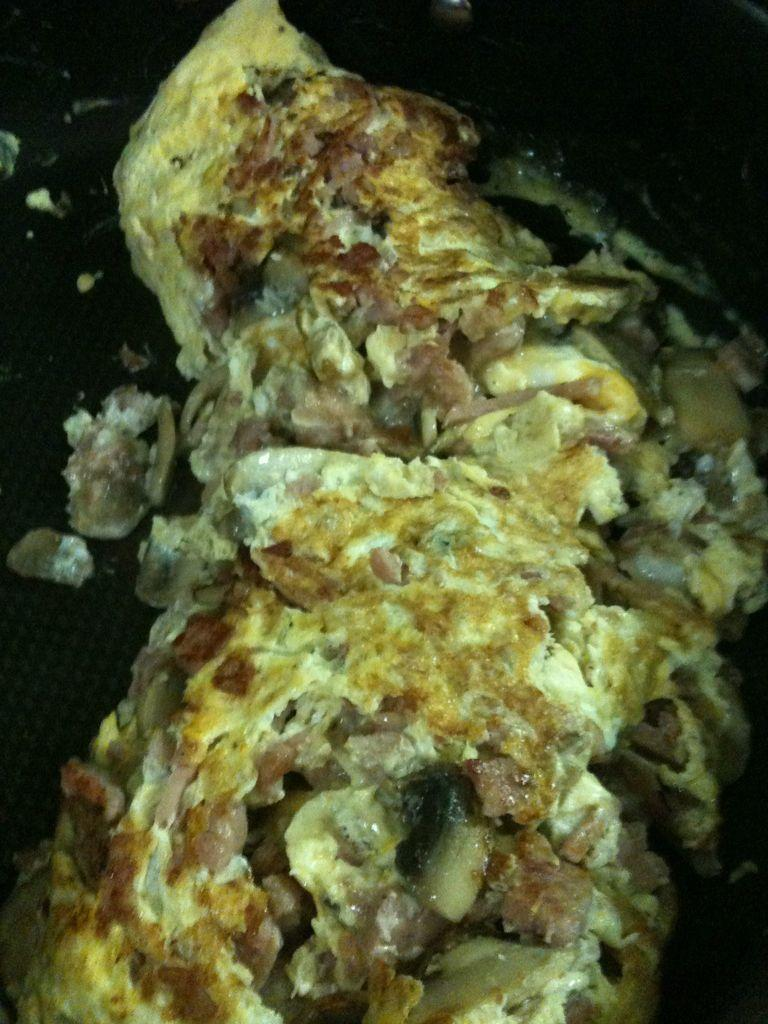What is present in the image? There is a container in the image. What is inside the container? The container has food items in it. Are there any flowers growing out of the container in the image? No, there are no flowers present in the image. 